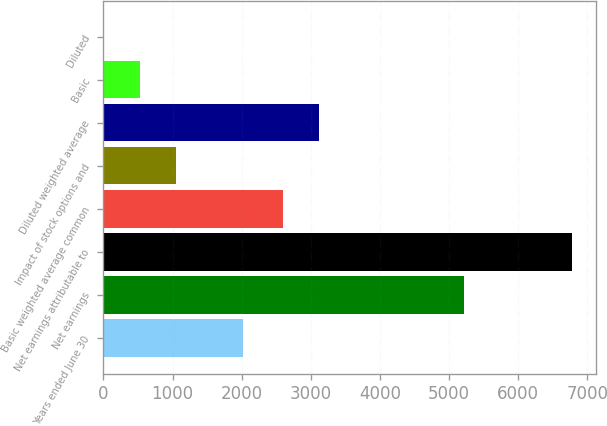Convert chart. <chart><loc_0><loc_0><loc_500><loc_500><bar_chart><fcel>Years ended June 30<fcel>Net earnings<fcel>Net earnings attributable to<fcel>Basic weighted average common<fcel>Impact of stock options and<fcel>Diluted weighted average<fcel>Basic<fcel>Diluted<nl><fcel>2017<fcel>5217<fcel>6781.53<fcel>2598.1<fcel>1044.92<fcel>3119.61<fcel>523.41<fcel>1.9<nl></chart> 